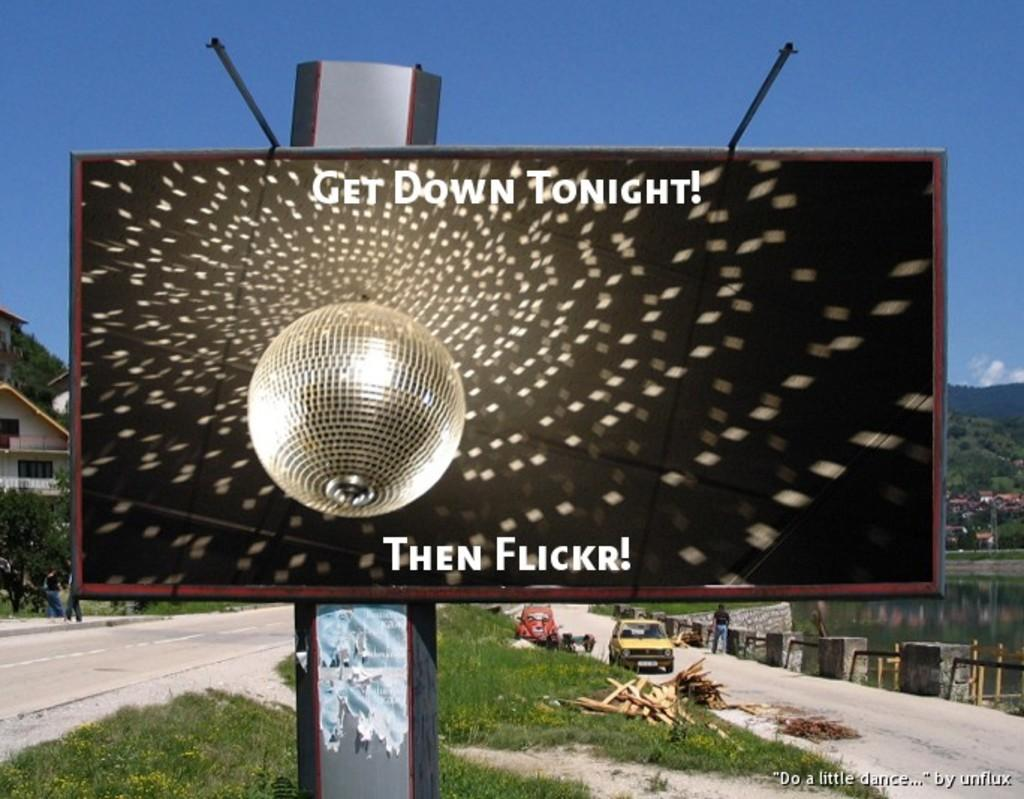<image>
Share a concise interpretation of the image provided. A sign has the words Get Down Tonight and shows a disco ball. 